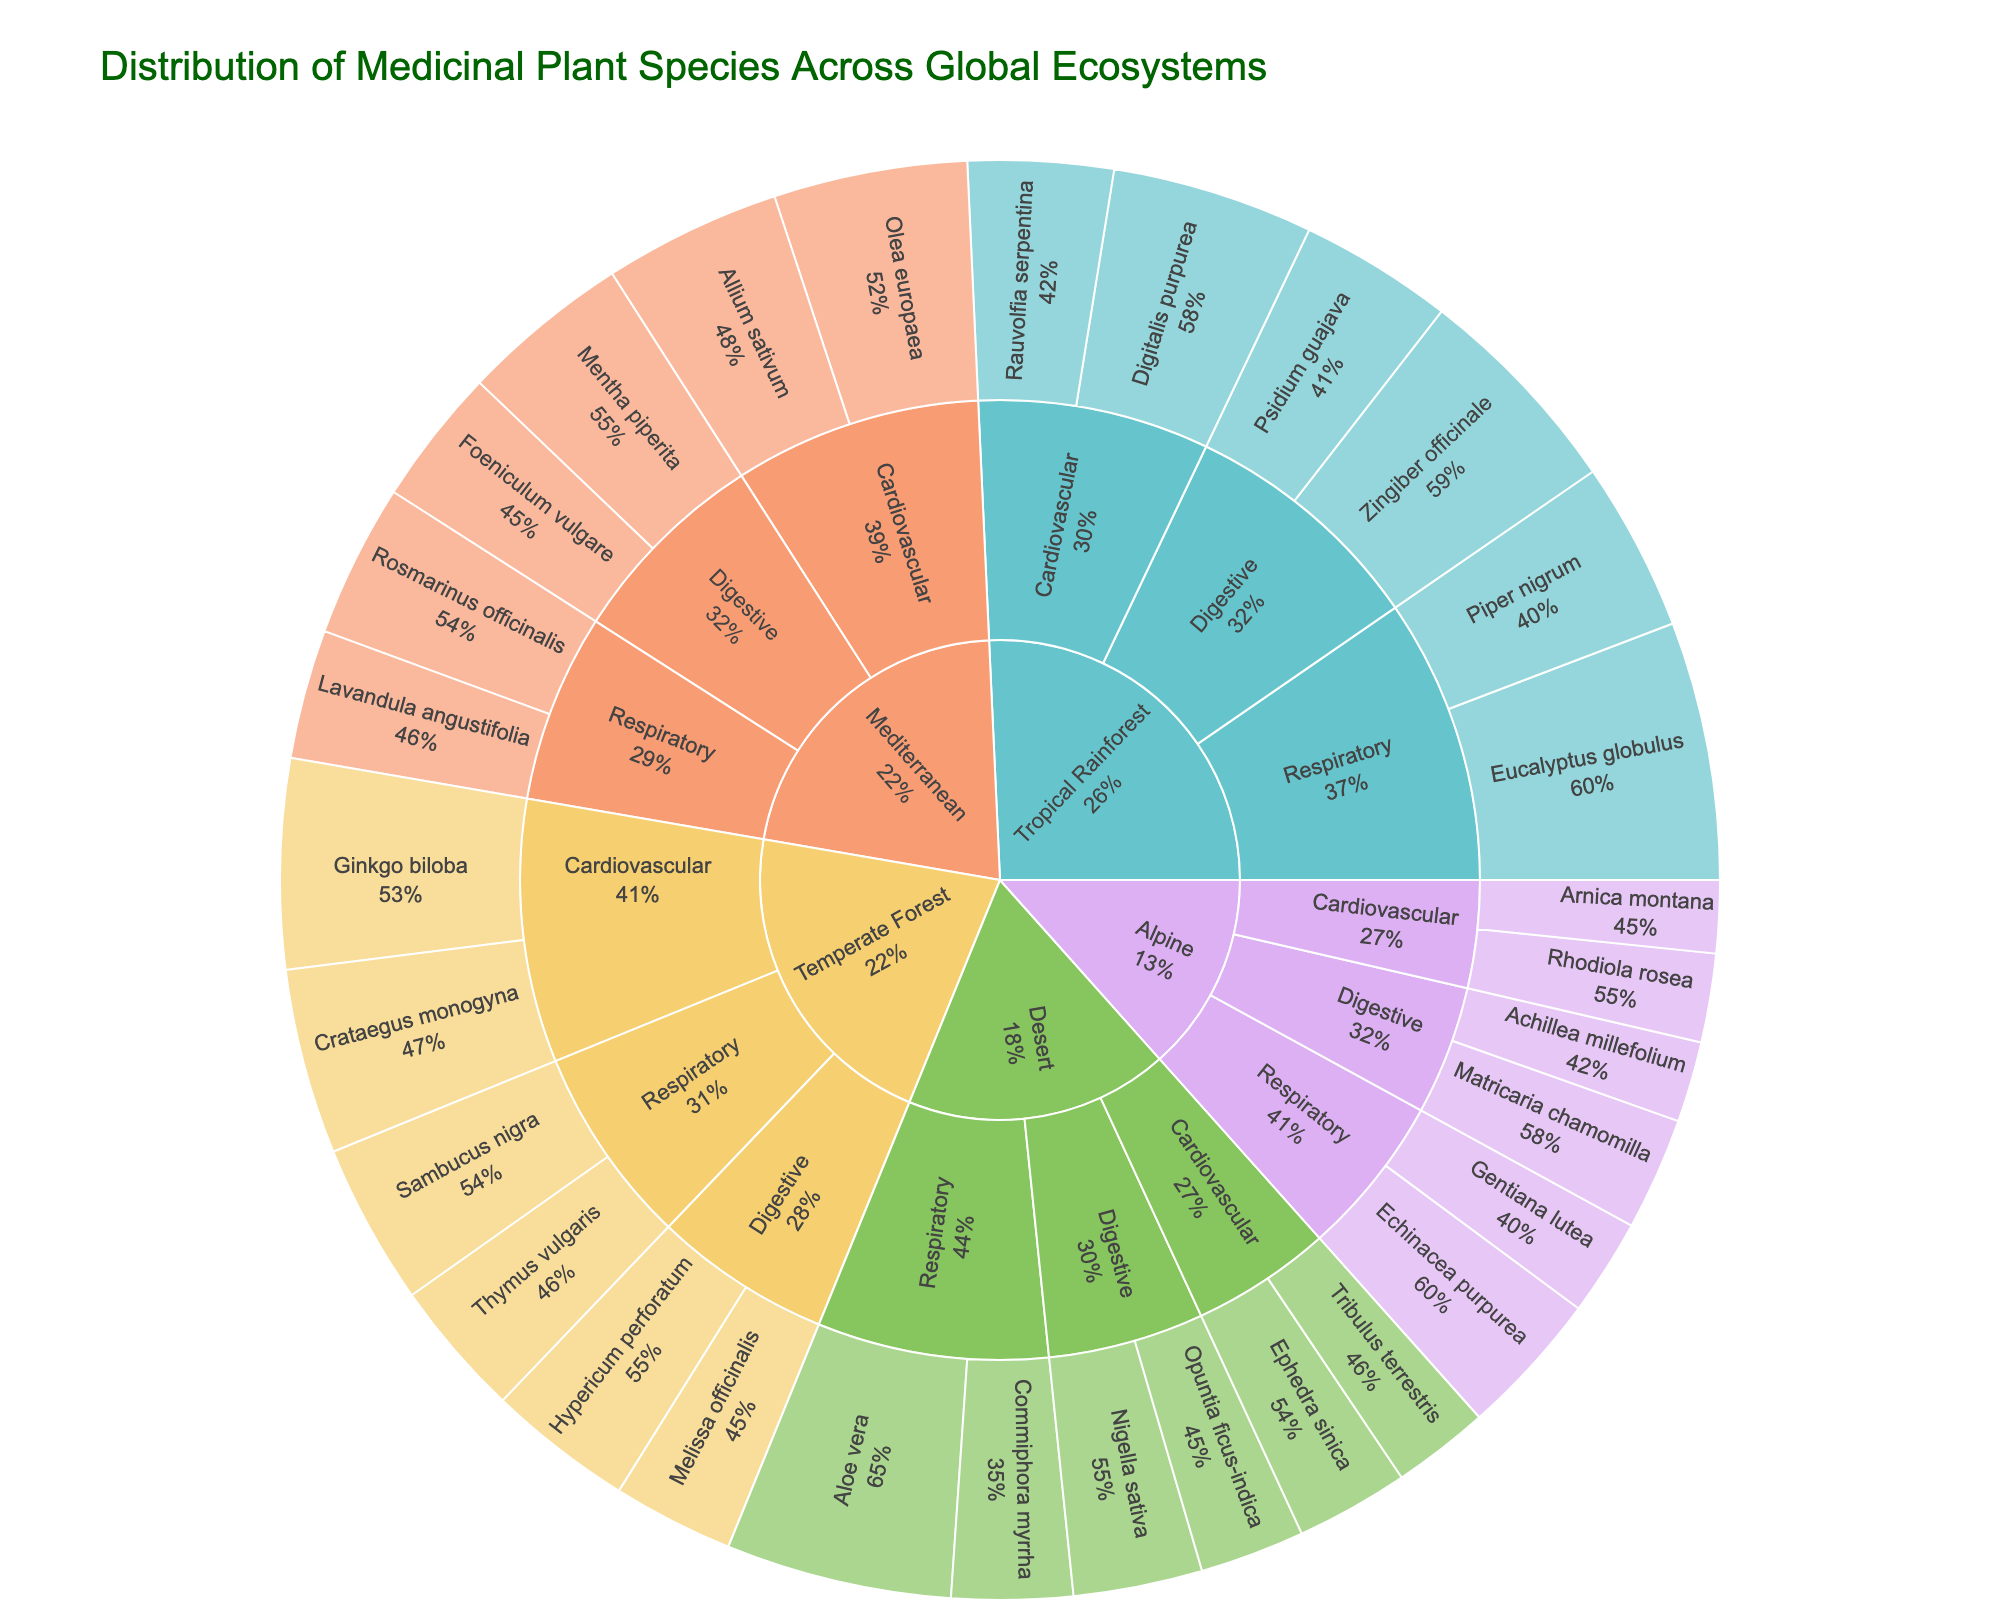What ecosystems are represented in the sunburst plot? The sunburst plot's outermost categories show the different ecosystems represented. These are Tropical Rainforest, Temperate Forest, Mediterranean, Desert, and Alpine.
Answer: Tropical Rainforest, Temperate Forest, Mediterranean, Desert, and Alpine Which ecosystem has the highest number of medicinal plant species? Looking at the first level of the sunburst plot, count the plant species segments under each ecosystem. Tropical Rainforest seems to have the most segments indicating it has the highest number of medicinal plant species.
Answer: Tropical Rainforest What therapeutic category in the Desert ecosystem has the highest percentage of plant species? Within the Desert ecosystem section of the sunburst plot, compare the percentage values of Cardiovascular, Respiratory, and Digestive categories. The Respiratory category has the highest percentage.
Answer: Respiratory What is the combined percentage of plants used for cardiovascular therapy in the Alpine ecosystem? In the Alpine section, sum the percentages of 'Rhodiola rosea' and 'Arnica montana' which are used for cardiovascular purposes. Calculate as 1.1% + 0.9% = 2.0%.
Answer: 2.0% Which therapeutic category has more plant species in the Temperate Forest: Respiratory or Digestive? In the Temperate Forest section, count the species in the Respiratory category (Thymus vulgaris and Sambucus nigra, i.e., 2) and the Digestive category (Melissa officinalis and Hypericum perforatum, i.e., 2). Both categories have the same number of plant species.
Answer: Equal What is the percentage difference between Respiratory plant species in Tropical Rainforest and Temperate Forest? Sum the percentages of Respiratory species in Tropical Rainforest (3.2% + 2.1% = 5.3%) and in Temperate Forest (1.7% + 2.0% = 3.7%), then calculate the difference: 5.3% - 3.7% = 1.6%.
Answer: 1.6% Among the listed Mediterranean plant species, which one has the highest percentage of use? Examine the percentages under the Mediterranean section for plant species. 'Mentha piperita' has the highest percentage at 2.1%.
Answer: Mentha piperita In the Tropical Rainforest, which therapeutic category has the least combined percentage of plant species? Compare the summed percentages for Cardiovascular (2.5% + 1.8% = 4.3%), Respiratory (3.2% + 2.1% = 5.3%), and Digestive (2.7% + 1.9% = 4.6%). Cardiovascular has the least.
Answer: Cardiovascular How many plant species are used for Digestive therapies in the entire dataset? Count the plant species segments tagged under Digestive in all sections of the sunburst plot. There are eight such species in total.
Answer: Eight Which ecosystem has the highest overall combined percentage for respiratory therapeutic plant use? Sum the percentages of respiratory plants for each ecosystem: 
- Tropical Rainforest: 3.2% + 2.1% = 5.3%
- Temperate Forest: 1.7% + 2.0% = 3.7%
- Mediterranean: 1.9% + 1.6% = 3.5%
- Desert: 2.8% + 1.5% = 4.3%
- Alpine: 1.8% + 1.2% = 3.0%
Tropical Rainforest has the highest combined percentage for respiratory therapeutic plants.
Answer: Tropical Rainforest 